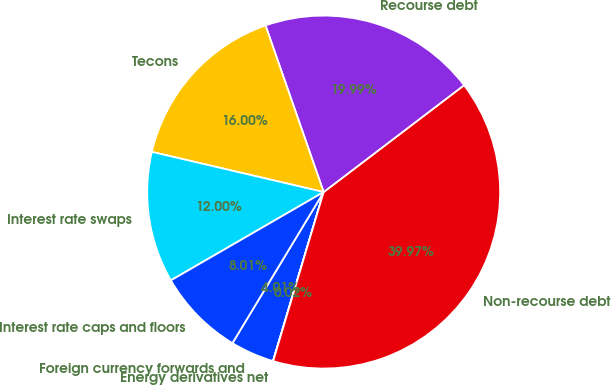<chart> <loc_0><loc_0><loc_500><loc_500><pie_chart><fcel>Foreign currency forwards and<fcel>Energy derivatives net<fcel>Non-recourse debt<fcel>Recourse debt<fcel>Tecons<fcel>Interest rate swaps<fcel>Interest rate caps and floors<nl><fcel>4.01%<fcel>0.02%<fcel>39.97%<fcel>19.99%<fcel>16.0%<fcel>12.0%<fcel>8.01%<nl></chart> 